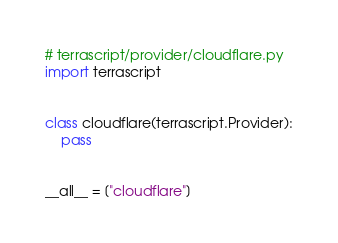Convert code to text. <code><loc_0><loc_0><loc_500><loc_500><_Python_># terrascript/provider/cloudflare.py
import terrascript


class cloudflare(terrascript.Provider):
    pass


__all__ = ["cloudflare"]
</code> 